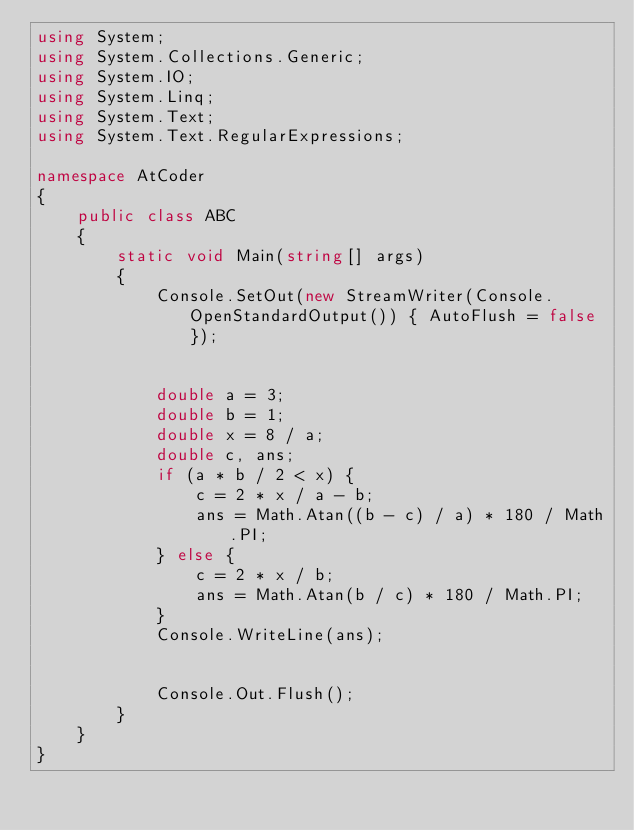Convert code to text. <code><loc_0><loc_0><loc_500><loc_500><_C#_>using System;
using System.Collections.Generic;
using System.IO;
using System.Linq;
using System.Text;
using System.Text.RegularExpressions;

namespace AtCoder
{
	public class ABC
	{
		static void Main(string[] args)
		{
			Console.SetOut(new StreamWriter(Console.OpenStandardOutput()) { AutoFlush = false });


			double a = 3;
			double b = 1;
			double x = 8 / a;
			double c, ans;
			if (a * b / 2 < x) {
				c = 2 * x / a - b;
				ans = Math.Atan((b - c) / a) * 180 / Math.PI;
			} else {
				c = 2 * x / b;
				ans = Math.Atan(b / c) * 180 / Math.PI;
			}
			Console.WriteLine(ans);


			Console.Out.Flush();
		}
	}
}
</code> 